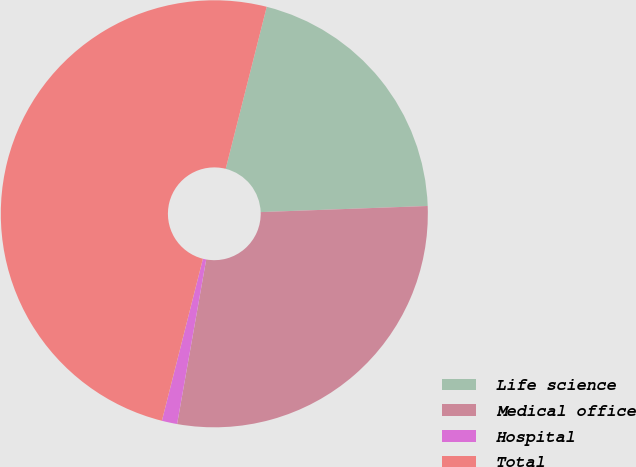Convert chart. <chart><loc_0><loc_0><loc_500><loc_500><pie_chart><fcel>Life science<fcel>Medical office<fcel>Hospital<fcel>Total<nl><fcel>20.47%<fcel>28.37%<fcel>1.16%<fcel>50.0%<nl></chart> 